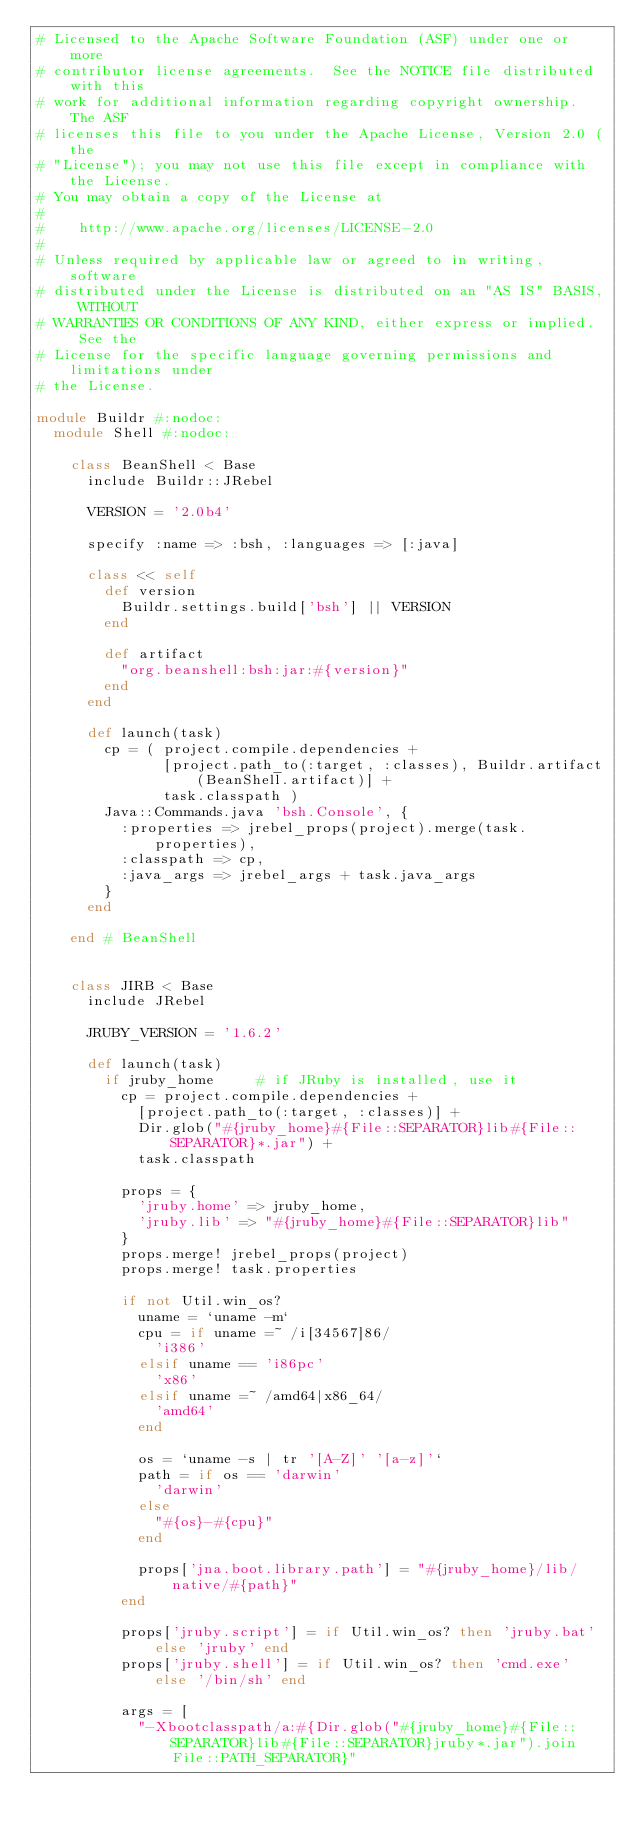<code> <loc_0><loc_0><loc_500><loc_500><_Ruby_># Licensed to the Apache Software Foundation (ASF) under one or more
# contributor license agreements.  See the NOTICE file distributed with this
# work for additional information regarding copyright ownership.  The ASF
# licenses this file to you under the Apache License, Version 2.0 (the
# "License"); you may not use this file except in compliance with the License.
# You may obtain a copy of the License at
#
#    http://www.apache.org/licenses/LICENSE-2.0
#
# Unless required by applicable law or agreed to in writing, software
# distributed under the License is distributed on an "AS IS" BASIS, WITHOUT
# WARRANTIES OR CONDITIONS OF ANY KIND, either express or implied.  See the
# License for the specific language governing permissions and limitations under
# the License.

module Buildr #:nodoc:
  module Shell #:nodoc:

    class BeanShell < Base
      include Buildr::JRebel

      VERSION = '2.0b4'

      specify :name => :bsh, :languages => [:java]

      class << self
        def version
          Buildr.settings.build['bsh'] || VERSION
        end

        def artifact
          "org.beanshell:bsh:jar:#{version}"
        end
      end

      def launch(task)
        cp = ( project.compile.dependencies +
               [project.path_to(:target, :classes), Buildr.artifact(BeanShell.artifact)] +
               task.classpath )
        Java::Commands.java 'bsh.Console', {
          :properties => jrebel_props(project).merge(task.properties),
          :classpath => cp,
          :java_args => jrebel_args + task.java_args
        }
      end

    end # BeanShell


    class JIRB < Base
      include JRebel

      JRUBY_VERSION = '1.6.2'

      def launch(task)
        if jruby_home     # if JRuby is installed, use it
          cp = project.compile.dependencies +
            [project.path_to(:target, :classes)] +
            Dir.glob("#{jruby_home}#{File::SEPARATOR}lib#{File::SEPARATOR}*.jar") +
            task.classpath

          props = {
            'jruby.home' => jruby_home,
            'jruby.lib' => "#{jruby_home}#{File::SEPARATOR}lib"
          }
          props.merge! jrebel_props(project)
          props.merge! task.properties

          if not Util.win_os?
            uname = `uname -m`
            cpu = if uname =~ /i[34567]86/
              'i386'
            elsif uname == 'i86pc'
              'x86'
            elsif uname =~ /amd64|x86_64/
              'amd64'
            end

            os = `uname -s | tr '[A-Z]' '[a-z]'`
            path = if os == 'darwin'
              'darwin'
            else
              "#{os}-#{cpu}"
            end

            props['jna.boot.library.path'] = "#{jruby_home}/lib/native/#{path}"
          end

          props['jruby.script'] = if Util.win_os? then 'jruby.bat' else 'jruby' end
          props['jruby.shell'] = if Util.win_os? then 'cmd.exe' else '/bin/sh' end

          args = [
            "-Xbootclasspath/a:#{Dir.glob("#{jruby_home}#{File::SEPARATOR}lib#{File::SEPARATOR}jruby*.jar").join File::PATH_SEPARATOR}"</code> 